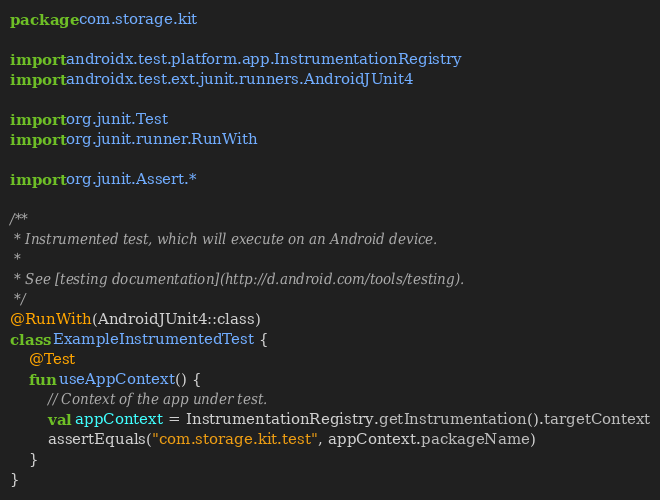<code> <loc_0><loc_0><loc_500><loc_500><_Kotlin_>package com.storage.kit

import androidx.test.platform.app.InstrumentationRegistry
import androidx.test.ext.junit.runners.AndroidJUnit4

import org.junit.Test
import org.junit.runner.RunWith

import org.junit.Assert.*

/**
 * Instrumented test, which will execute on an Android device.
 *
 * See [testing documentation](http://d.android.com/tools/testing).
 */
@RunWith(AndroidJUnit4::class)
class ExampleInstrumentedTest {
    @Test
    fun useAppContext() {
        // Context of the app under test.
        val appContext = InstrumentationRegistry.getInstrumentation().targetContext
        assertEquals("com.storage.kit.test", appContext.packageName)
    }
}</code> 